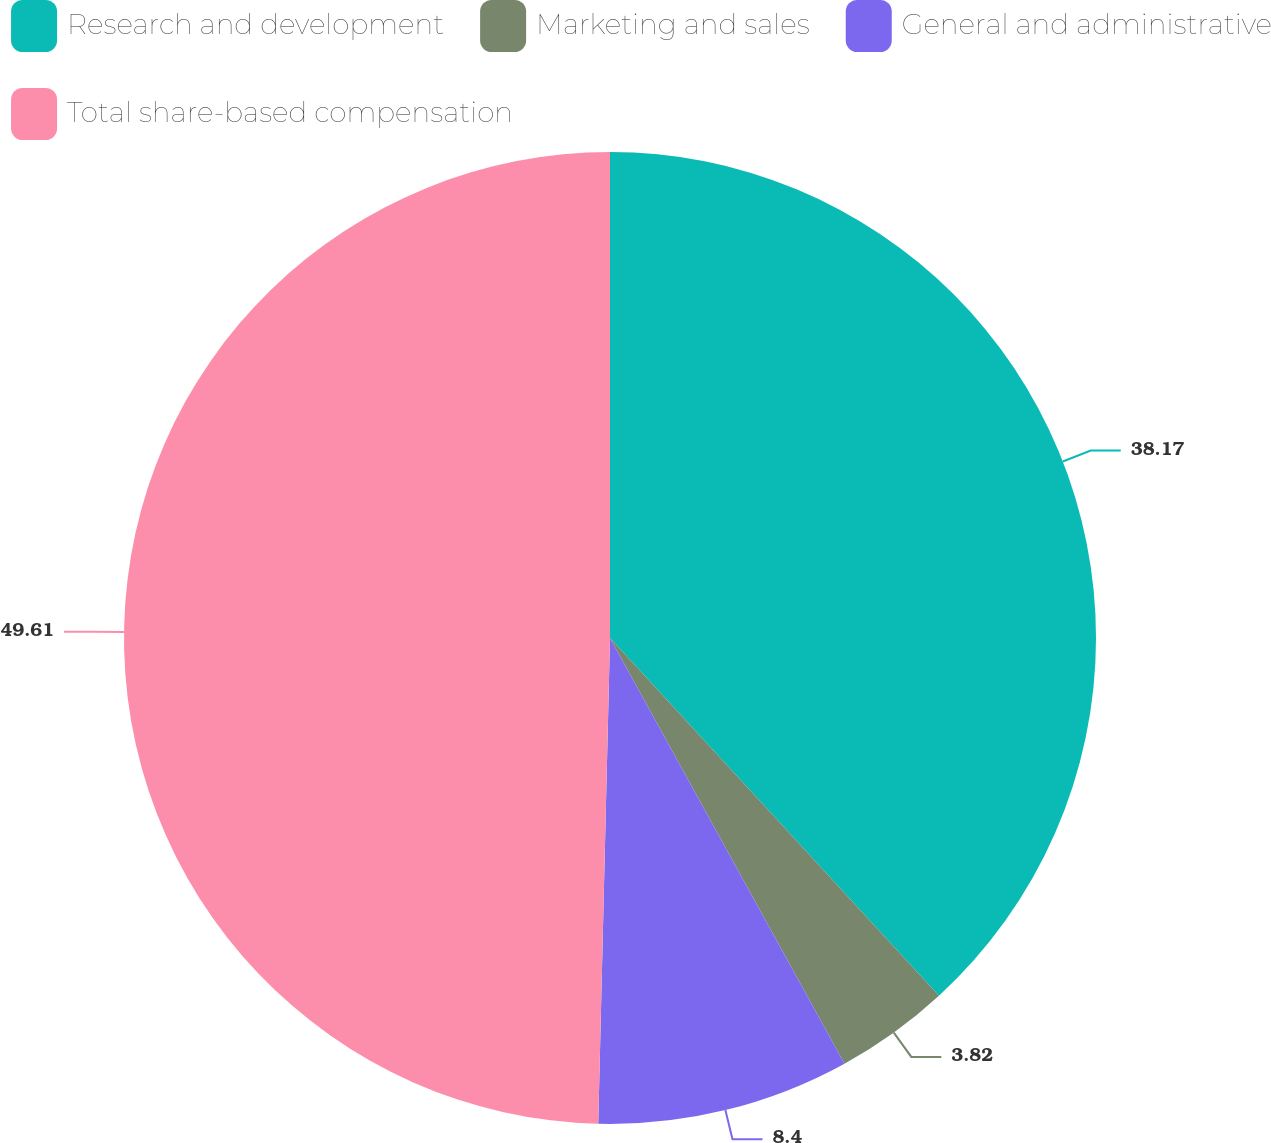<chart> <loc_0><loc_0><loc_500><loc_500><pie_chart><fcel>Research and development<fcel>Marketing and sales<fcel>General and administrative<fcel>Total share-based compensation<nl><fcel>38.17%<fcel>3.82%<fcel>8.4%<fcel>49.62%<nl></chart> 